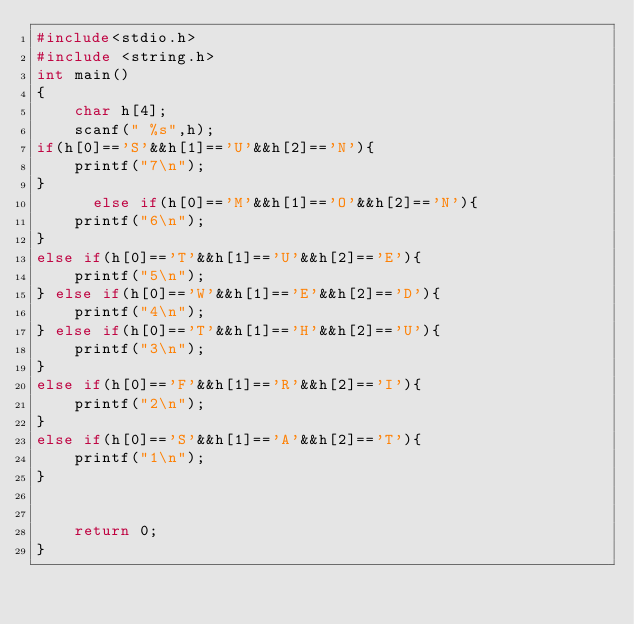Convert code to text. <code><loc_0><loc_0><loc_500><loc_500><_C_>#include<stdio.h>
#include <string.h>
int main()
{
    char h[4];
    scanf(" %s",h);
if(h[0]=='S'&&h[1]=='U'&&h[2]=='N'){
    printf("7\n");
}
      else if(h[0]=='M'&&h[1]=='O'&&h[2]=='N'){
    printf("6\n");
}
else if(h[0]=='T'&&h[1]=='U'&&h[2]=='E'){
    printf("5\n");
} else if(h[0]=='W'&&h[1]=='E'&&h[2]=='D'){
    printf("4\n");
} else if(h[0]=='T'&&h[1]=='H'&&h[2]=='U'){
    printf("3\n");
}
else if(h[0]=='F'&&h[1]=='R'&&h[2]=='I'){
    printf("2\n");
}
else if(h[0]=='S'&&h[1]=='A'&&h[2]=='T'){
    printf("1\n");
}


    return 0;
}
</code> 